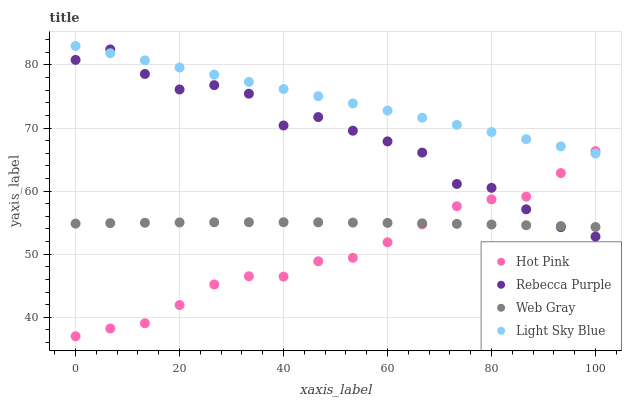Does Hot Pink have the minimum area under the curve?
Answer yes or no. Yes. Does Light Sky Blue have the maximum area under the curve?
Answer yes or no. Yes. Does Web Gray have the minimum area under the curve?
Answer yes or no. No. Does Web Gray have the maximum area under the curve?
Answer yes or no. No. Is Light Sky Blue the smoothest?
Answer yes or no. Yes. Is Rebecca Purple the roughest?
Answer yes or no. Yes. Is Web Gray the smoothest?
Answer yes or no. No. Is Web Gray the roughest?
Answer yes or no. No. Does Hot Pink have the lowest value?
Answer yes or no. Yes. Does Web Gray have the lowest value?
Answer yes or no. No. Does Light Sky Blue have the highest value?
Answer yes or no. Yes. Does Rebecca Purple have the highest value?
Answer yes or no. No. Is Web Gray less than Light Sky Blue?
Answer yes or no. Yes. Is Light Sky Blue greater than Web Gray?
Answer yes or no. Yes. Does Rebecca Purple intersect Web Gray?
Answer yes or no. Yes. Is Rebecca Purple less than Web Gray?
Answer yes or no. No. Is Rebecca Purple greater than Web Gray?
Answer yes or no. No. Does Web Gray intersect Light Sky Blue?
Answer yes or no. No. 